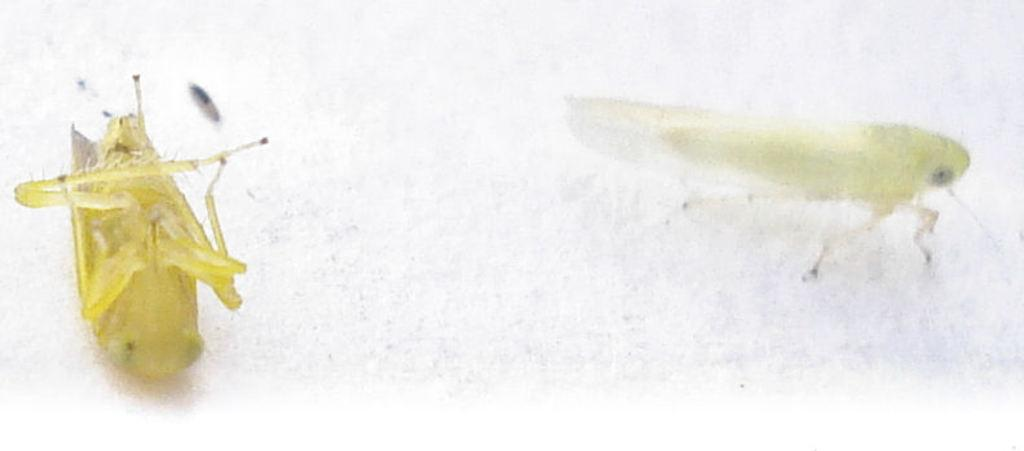How many insects are present in the image? There are two insects in the image. What color are the insects? The insects are yellow in color. What type of thread is being used by the insects in the image? There is no thread present in the image, as it features two yellow insects. 